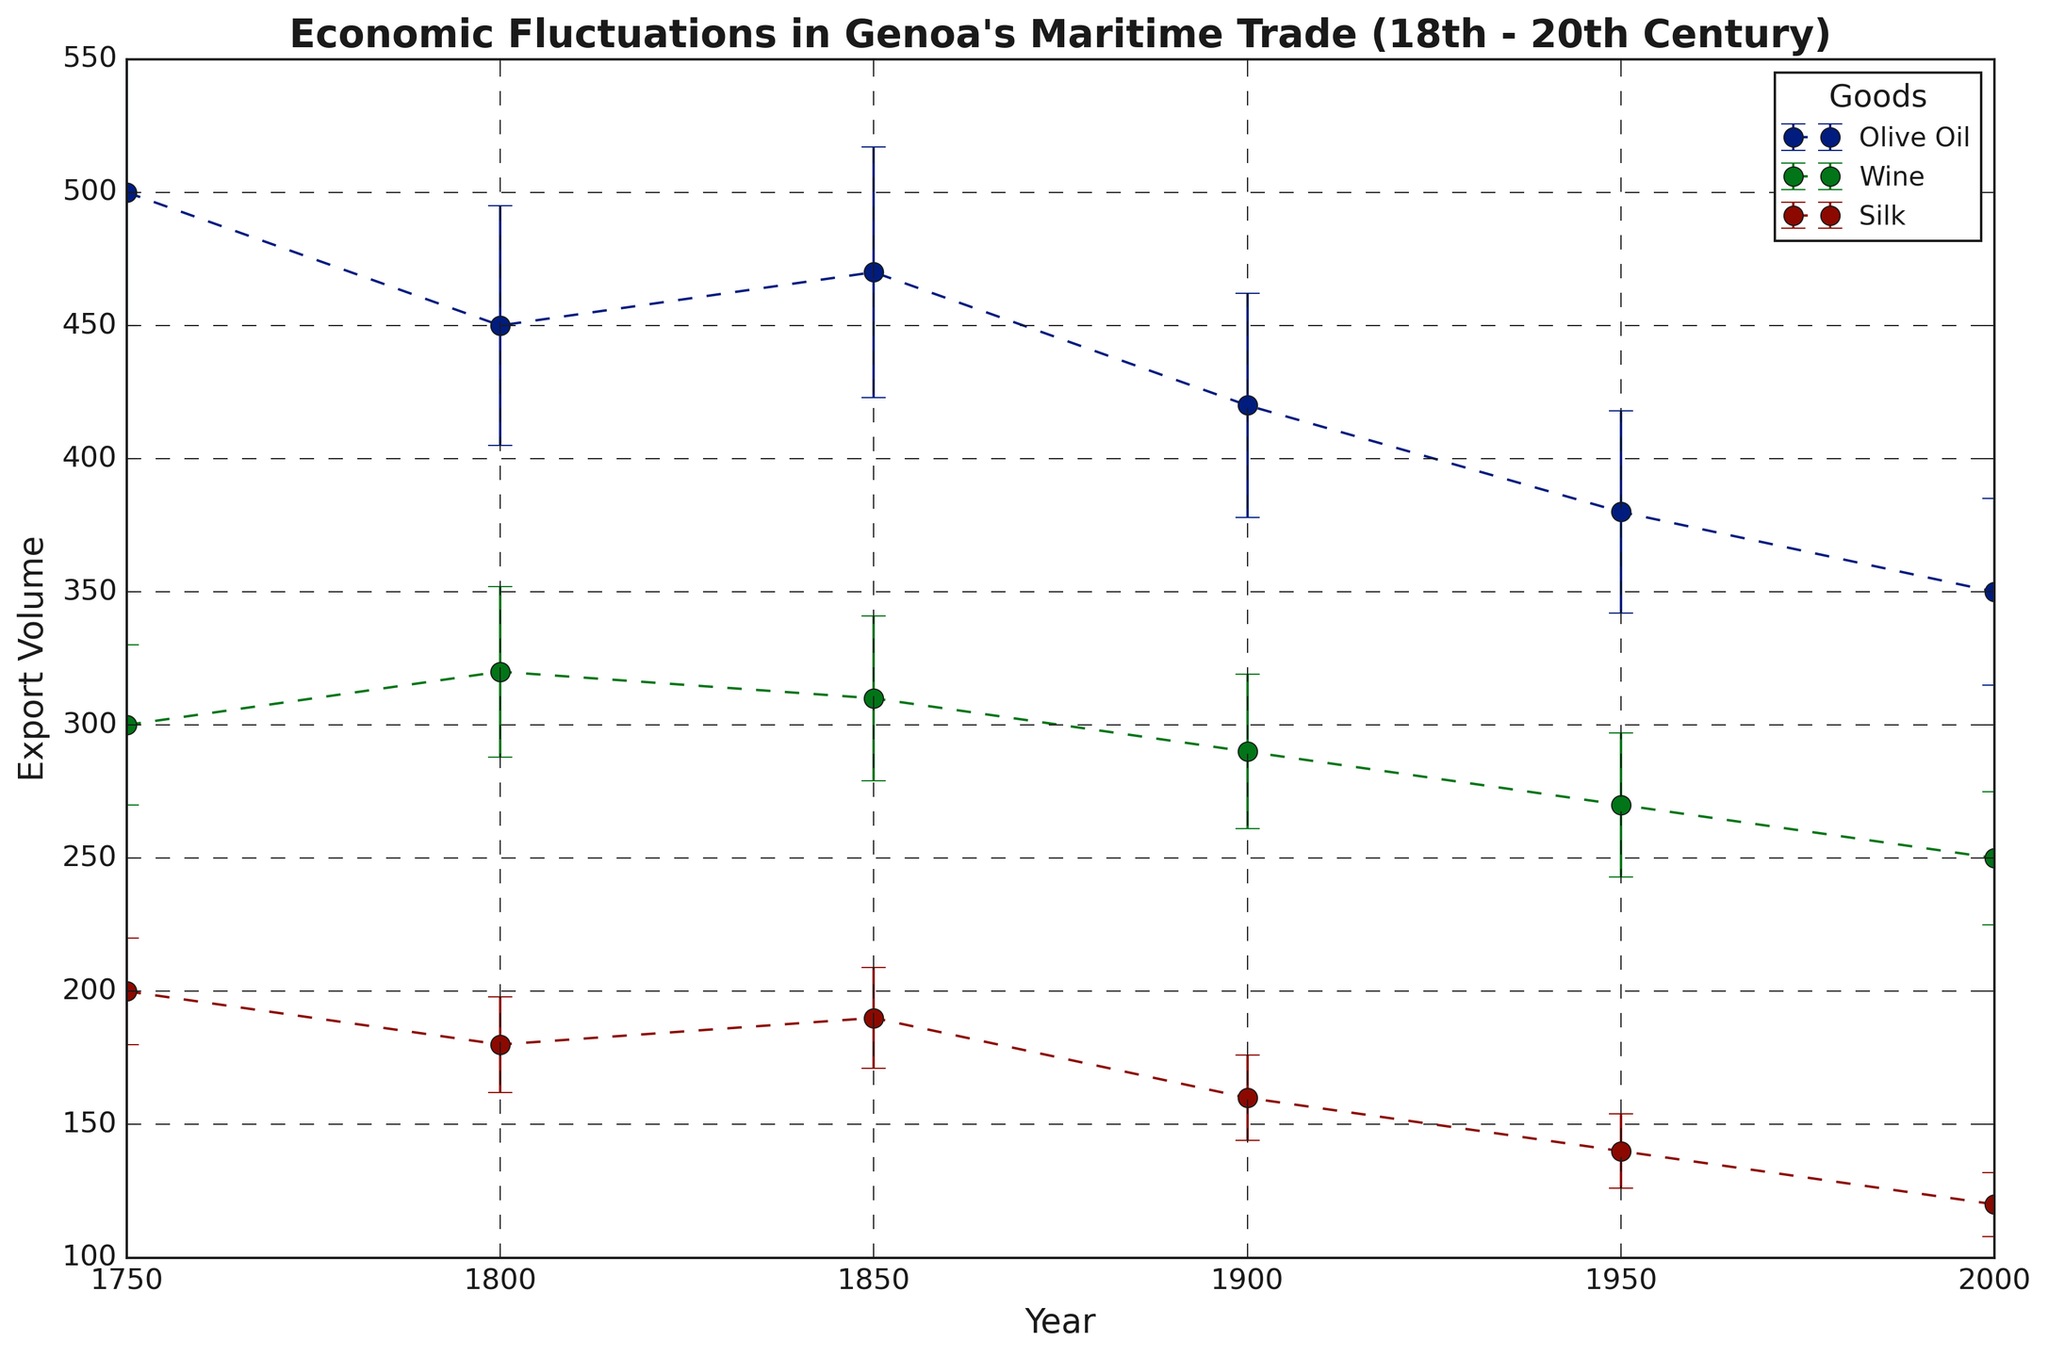How did the export volume of Olive Oil change from 1750 to 2000? First, we observe the export volume of Olive Oil in 1750, which is 500. Then, we look at the export volume of Olive Oil in 2000, which is 350. The change is calculated as 350 - 500 = -150, indicating a decrease of 150.
Answer: It decreased by 150 Between which two consecutive time periods did Silk export volume experience the greatest increase? We compare the export volumes of Silk across each consecutive period. From 1750 to 1800, it changed from 200 to 180 (a decrease). From 1800 to 1850, it changed from 180 to 190 (an increase of 10). From 1850 to 1900, it changed from 190 to 160 (a decrease). From 1900 to 1950, it changed from 160 to 140 (a decrease). From 1950 to 2000, it changed from 140 to 120 (a decrease). Therefore, the greatest increase was from 1800 to 1850, where it increased by 10.
Answer: From 1800 to 1850 Which good had the highest export volume in 1850? We look at the export volumes of all goods in 1850. Olive Oil had 470, Wine had 310, and Silk had 190. Therefore, Olive Oil had the highest export volume in 1850.
Answer: Olive Oil Which goods show a consistent decline in export volume over the entire period? Observing each good separately: Olive Oil shows a decrease from 500 to 350 over the selected years. Wine decreases from 300 to 250. Silk decreases from 200 to 120. Therefore, all goods show a consistent decline over time.
Answer: Olive Oil, Wine, Silk What was the total export volume for Wine across all given years? We sum up the export volumes of Wine for each year: 300 (1750) + 320 (1800) + 310 (1850) + 290 (1900) + 270 (1950) + 250 (2000), which is 1740.
Answer: 1740 How does the error bar of Olive Oil in 1750 compare to Silk in 1800? We look at the lengths of the error bars. Olive Oil in 1750 has an error of 50. Silk in 1800 has an error of 18. Therefore, the error bar for Olive Oil in 1750 is greater than that of Silk in 1800.
Answer: Olive Oil's error bar in 1750 is greater by 32 For which good and year combination is the error in export volume the lowest? We observe the error values for each good and each year. The lowest error value is for Silk in 2000, which is 12.
Answer: Silk in 2000 What is the average export volume of Olive Oil over the entire period? We calculate the mean of the Olive Oil export volumes: (500 + 450 + 470 + 420 + 380 + 350) / 6. First, sum these values: 500 + 450 + 470 + 420 + 380 + 350 = 2570. Then, divide by the number of data points (6): 2570 / 6 ≈ 428.33.
Answer: 428.33 